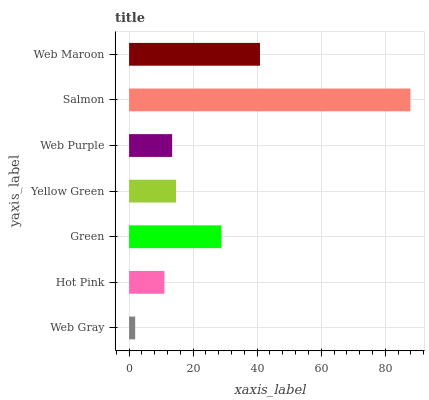Is Web Gray the minimum?
Answer yes or no. Yes. Is Salmon the maximum?
Answer yes or no. Yes. Is Hot Pink the minimum?
Answer yes or no. No. Is Hot Pink the maximum?
Answer yes or no. No. Is Hot Pink greater than Web Gray?
Answer yes or no. Yes. Is Web Gray less than Hot Pink?
Answer yes or no. Yes. Is Web Gray greater than Hot Pink?
Answer yes or no. No. Is Hot Pink less than Web Gray?
Answer yes or no. No. Is Yellow Green the high median?
Answer yes or no. Yes. Is Yellow Green the low median?
Answer yes or no. Yes. Is Web Purple the high median?
Answer yes or no. No. Is Web Purple the low median?
Answer yes or no. No. 